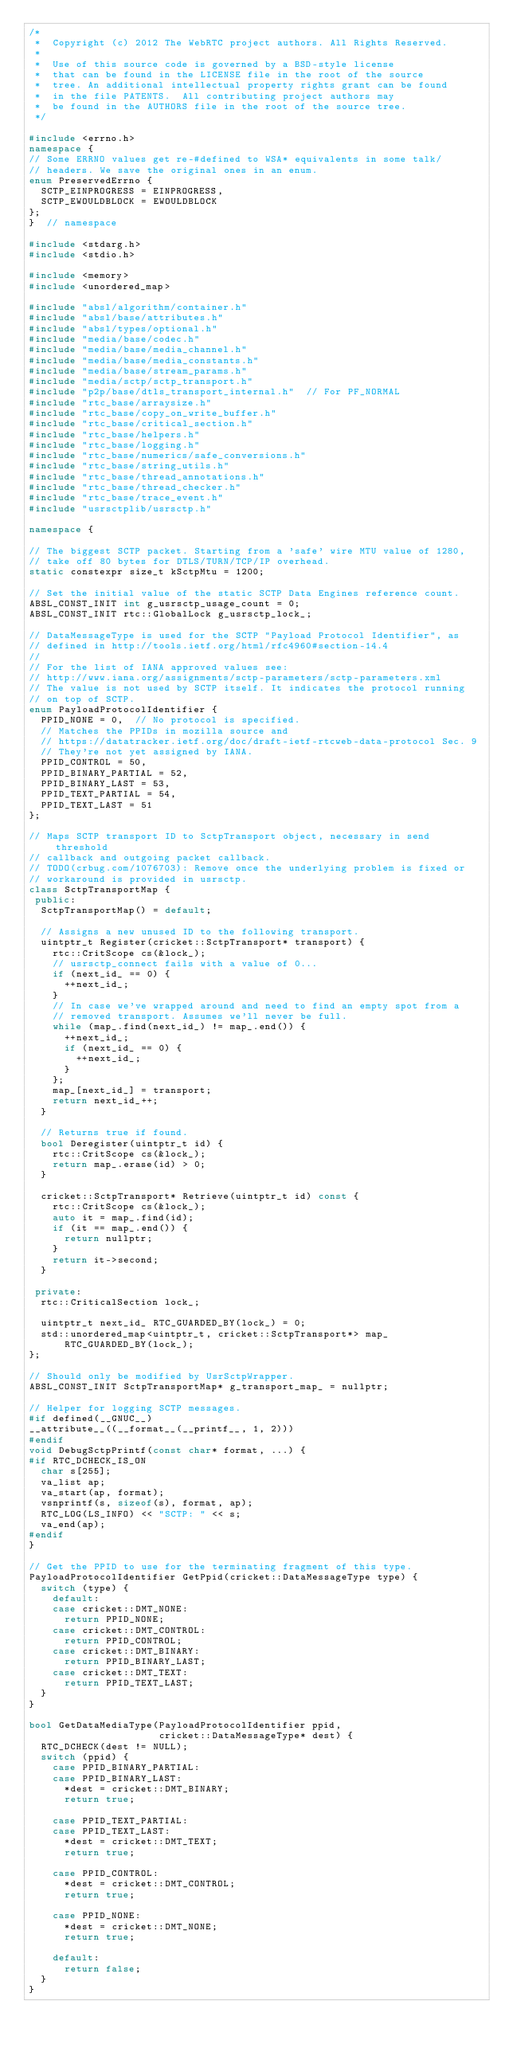Convert code to text. <code><loc_0><loc_0><loc_500><loc_500><_C++_>/*
 *  Copyright (c) 2012 The WebRTC project authors. All Rights Reserved.
 *
 *  Use of this source code is governed by a BSD-style license
 *  that can be found in the LICENSE file in the root of the source
 *  tree. An additional intellectual property rights grant can be found
 *  in the file PATENTS.  All contributing project authors may
 *  be found in the AUTHORS file in the root of the source tree.
 */

#include <errno.h>
namespace {
// Some ERRNO values get re-#defined to WSA* equivalents in some talk/
// headers. We save the original ones in an enum.
enum PreservedErrno {
  SCTP_EINPROGRESS = EINPROGRESS,
  SCTP_EWOULDBLOCK = EWOULDBLOCK
};
}  // namespace

#include <stdarg.h>
#include <stdio.h>

#include <memory>
#include <unordered_map>

#include "absl/algorithm/container.h"
#include "absl/base/attributes.h"
#include "absl/types/optional.h"
#include "media/base/codec.h"
#include "media/base/media_channel.h"
#include "media/base/media_constants.h"
#include "media/base/stream_params.h"
#include "media/sctp/sctp_transport.h"
#include "p2p/base/dtls_transport_internal.h"  // For PF_NORMAL
#include "rtc_base/arraysize.h"
#include "rtc_base/copy_on_write_buffer.h"
#include "rtc_base/critical_section.h"
#include "rtc_base/helpers.h"
#include "rtc_base/logging.h"
#include "rtc_base/numerics/safe_conversions.h"
#include "rtc_base/string_utils.h"
#include "rtc_base/thread_annotations.h"
#include "rtc_base/thread_checker.h"
#include "rtc_base/trace_event.h"
#include "usrsctplib/usrsctp.h"

namespace {

// The biggest SCTP packet. Starting from a 'safe' wire MTU value of 1280,
// take off 80 bytes for DTLS/TURN/TCP/IP overhead.
static constexpr size_t kSctpMtu = 1200;

// Set the initial value of the static SCTP Data Engines reference count.
ABSL_CONST_INIT int g_usrsctp_usage_count = 0;
ABSL_CONST_INIT rtc::GlobalLock g_usrsctp_lock_;

// DataMessageType is used for the SCTP "Payload Protocol Identifier", as
// defined in http://tools.ietf.org/html/rfc4960#section-14.4
//
// For the list of IANA approved values see:
// http://www.iana.org/assignments/sctp-parameters/sctp-parameters.xml
// The value is not used by SCTP itself. It indicates the protocol running
// on top of SCTP.
enum PayloadProtocolIdentifier {
  PPID_NONE = 0,  // No protocol is specified.
  // Matches the PPIDs in mozilla source and
  // https://datatracker.ietf.org/doc/draft-ietf-rtcweb-data-protocol Sec. 9
  // They're not yet assigned by IANA.
  PPID_CONTROL = 50,
  PPID_BINARY_PARTIAL = 52,
  PPID_BINARY_LAST = 53,
  PPID_TEXT_PARTIAL = 54,
  PPID_TEXT_LAST = 51
};

// Maps SCTP transport ID to SctpTransport object, necessary in send threshold
// callback and outgoing packet callback.
// TODO(crbug.com/1076703): Remove once the underlying problem is fixed or
// workaround is provided in usrsctp.
class SctpTransportMap {
 public:
  SctpTransportMap() = default;

  // Assigns a new unused ID to the following transport.
  uintptr_t Register(cricket::SctpTransport* transport) {
    rtc::CritScope cs(&lock_);
    // usrsctp_connect fails with a value of 0...
    if (next_id_ == 0) {
      ++next_id_;
    }
    // In case we've wrapped around and need to find an empty spot from a
    // removed transport. Assumes we'll never be full.
    while (map_.find(next_id_) != map_.end()) {
      ++next_id_;
      if (next_id_ == 0) {
        ++next_id_;
      }
    };
    map_[next_id_] = transport;
    return next_id_++;
  }

  // Returns true if found.
  bool Deregister(uintptr_t id) {
    rtc::CritScope cs(&lock_);
    return map_.erase(id) > 0;
  }

  cricket::SctpTransport* Retrieve(uintptr_t id) const {
    rtc::CritScope cs(&lock_);
    auto it = map_.find(id);
    if (it == map_.end()) {
      return nullptr;
    }
    return it->second;
  }

 private:
  rtc::CriticalSection lock_;

  uintptr_t next_id_ RTC_GUARDED_BY(lock_) = 0;
  std::unordered_map<uintptr_t, cricket::SctpTransport*> map_
      RTC_GUARDED_BY(lock_);
};

// Should only be modified by UsrSctpWrapper.
ABSL_CONST_INIT SctpTransportMap* g_transport_map_ = nullptr;

// Helper for logging SCTP messages.
#if defined(__GNUC__)
__attribute__((__format__(__printf__, 1, 2)))
#endif
void DebugSctpPrintf(const char* format, ...) {
#if RTC_DCHECK_IS_ON
  char s[255];
  va_list ap;
  va_start(ap, format);
  vsnprintf(s, sizeof(s), format, ap);
  RTC_LOG(LS_INFO) << "SCTP: " << s;
  va_end(ap);
#endif
}

// Get the PPID to use for the terminating fragment of this type.
PayloadProtocolIdentifier GetPpid(cricket::DataMessageType type) {
  switch (type) {
    default:
    case cricket::DMT_NONE:
      return PPID_NONE;
    case cricket::DMT_CONTROL:
      return PPID_CONTROL;
    case cricket::DMT_BINARY:
      return PPID_BINARY_LAST;
    case cricket::DMT_TEXT:
      return PPID_TEXT_LAST;
  }
}

bool GetDataMediaType(PayloadProtocolIdentifier ppid,
                      cricket::DataMessageType* dest) {
  RTC_DCHECK(dest != NULL);
  switch (ppid) {
    case PPID_BINARY_PARTIAL:
    case PPID_BINARY_LAST:
      *dest = cricket::DMT_BINARY;
      return true;

    case PPID_TEXT_PARTIAL:
    case PPID_TEXT_LAST:
      *dest = cricket::DMT_TEXT;
      return true;

    case PPID_CONTROL:
      *dest = cricket::DMT_CONTROL;
      return true;

    case PPID_NONE:
      *dest = cricket::DMT_NONE;
      return true;

    default:
      return false;
  }
}
</code> 